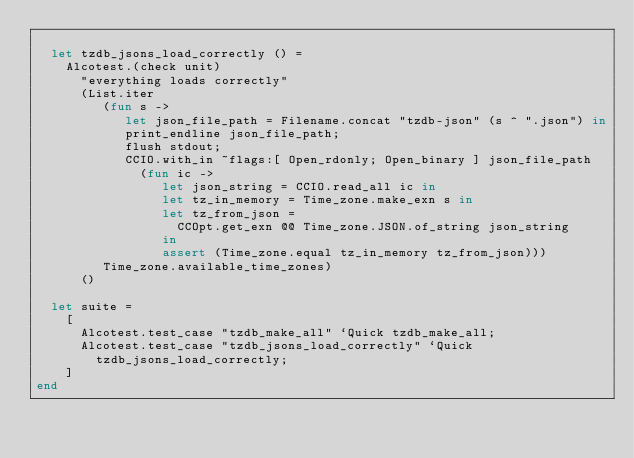<code> <loc_0><loc_0><loc_500><loc_500><_OCaml_>
  let tzdb_jsons_load_correctly () =
    Alcotest.(check unit)
      "everything loads correctly"
      (List.iter
         (fun s ->
            let json_file_path = Filename.concat "tzdb-json" (s ^ ".json") in
            print_endline json_file_path;
            flush stdout;
            CCIO.with_in ~flags:[ Open_rdonly; Open_binary ] json_file_path
              (fun ic ->
                 let json_string = CCIO.read_all ic in
                 let tz_in_memory = Time_zone.make_exn s in
                 let tz_from_json =
                   CCOpt.get_exn @@ Time_zone.JSON.of_string json_string
                 in
                 assert (Time_zone.equal tz_in_memory tz_from_json)))
         Time_zone.available_time_zones)
      ()

  let suite =
    [
      Alcotest.test_case "tzdb_make_all" `Quick tzdb_make_all;
      Alcotest.test_case "tzdb_jsons_load_correctly" `Quick
        tzdb_jsons_load_correctly;
    ]
end
</code> 